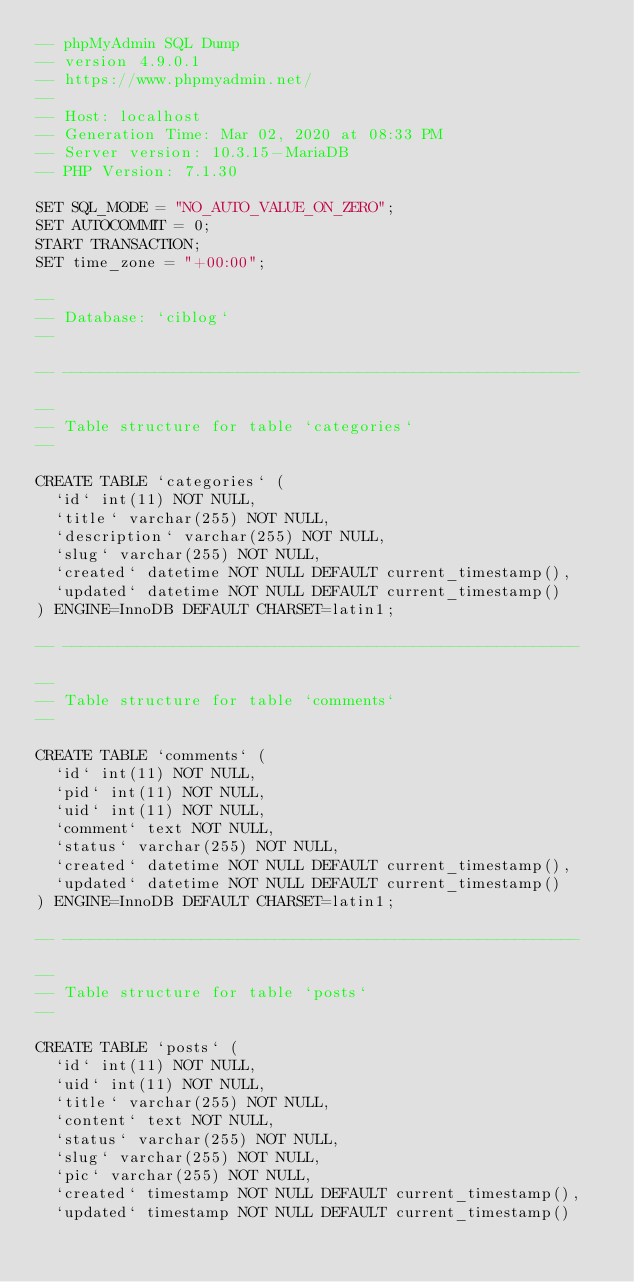Convert code to text. <code><loc_0><loc_0><loc_500><loc_500><_SQL_>-- phpMyAdmin SQL Dump
-- version 4.9.0.1
-- https://www.phpmyadmin.net/
--
-- Host: localhost
-- Generation Time: Mar 02, 2020 at 08:33 PM
-- Server version: 10.3.15-MariaDB
-- PHP Version: 7.1.30

SET SQL_MODE = "NO_AUTO_VALUE_ON_ZERO";
SET AUTOCOMMIT = 0;
START TRANSACTION;
SET time_zone = "+00:00";

--
-- Database: `ciblog`
--

-- --------------------------------------------------------

--
-- Table structure for table `categories`
--

CREATE TABLE `categories` (
  `id` int(11) NOT NULL,
  `title` varchar(255) NOT NULL,
  `description` varchar(255) NOT NULL,
  `slug` varchar(255) NOT NULL,
  `created` datetime NOT NULL DEFAULT current_timestamp(),
  `updated` datetime NOT NULL DEFAULT current_timestamp()
) ENGINE=InnoDB DEFAULT CHARSET=latin1;

-- --------------------------------------------------------

--
-- Table structure for table `comments`
--

CREATE TABLE `comments` (
  `id` int(11) NOT NULL,
  `pid` int(11) NOT NULL,
  `uid` int(11) NOT NULL,
  `comment` text NOT NULL,
  `status` varchar(255) NOT NULL,
  `created` datetime NOT NULL DEFAULT current_timestamp(),
  `updated` datetime NOT NULL DEFAULT current_timestamp()
) ENGINE=InnoDB DEFAULT CHARSET=latin1;

-- --------------------------------------------------------

--
-- Table structure for table `posts`
--

CREATE TABLE `posts` (
  `id` int(11) NOT NULL,
  `uid` int(11) NOT NULL,
  `title` varchar(255) NOT NULL,
  `content` text NOT NULL,
  `status` varchar(255) NOT NULL,
  `slug` varchar(255) NOT NULL,
  `pic` varchar(255) NOT NULL,
  `created` timestamp NOT NULL DEFAULT current_timestamp(),
  `updated` timestamp NOT NULL DEFAULT current_timestamp()</code> 